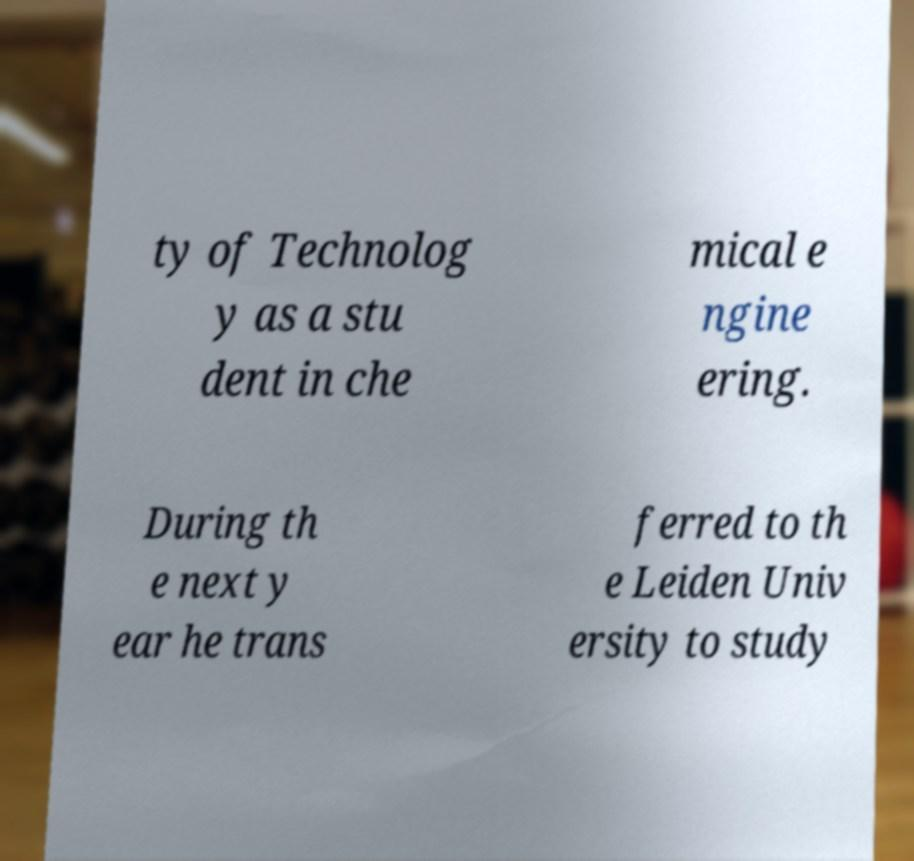Can you read and provide the text displayed in the image?This photo seems to have some interesting text. Can you extract and type it out for me? ty of Technolog y as a stu dent in che mical e ngine ering. During th e next y ear he trans ferred to th e Leiden Univ ersity to study 